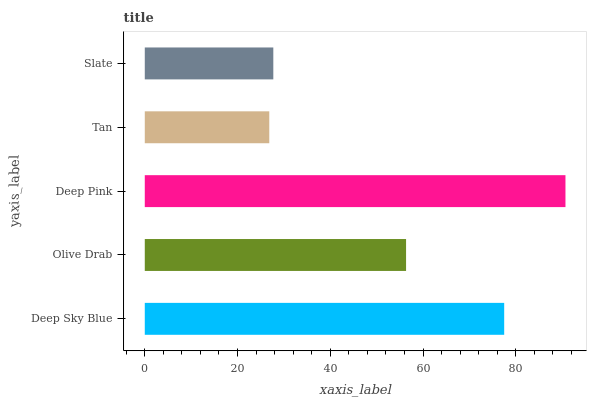Is Tan the minimum?
Answer yes or no. Yes. Is Deep Pink the maximum?
Answer yes or no. Yes. Is Olive Drab the minimum?
Answer yes or no. No. Is Olive Drab the maximum?
Answer yes or no. No. Is Deep Sky Blue greater than Olive Drab?
Answer yes or no. Yes. Is Olive Drab less than Deep Sky Blue?
Answer yes or no. Yes. Is Olive Drab greater than Deep Sky Blue?
Answer yes or no. No. Is Deep Sky Blue less than Olive Drab?
Answer yes or no. No. Is Olive Drab the high median?
Answer yes or no. Yes. Is Olive Drab the low median?
Answer yes or no. Yes. Is Tan the high median?
Answer yes or no. No. Is Slate the low median?
Answer yes or no. No. 